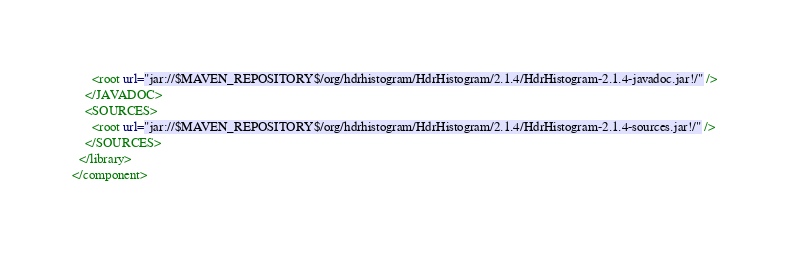Convert code to text. <code><loc_0><loc_0><loc_500><loc_500><_XML_>      <root url="jar://$MAVEN_REPOSITORY$/org/hdrhistogram/HdrHistogram/2.1.4/HdrHistogram-2.1.4-javadoc.jar!/" />
    </JAVADOC>
    <SOURCES>
      <root url="jar://$MAVEN_REPOSITORY$/org/hdrhistogram/HdrHistogram/2.1.4/HdrHistogram-2.1.4-sources.jar!/" />
    </SOURCES>
  </library>
</component></code> 